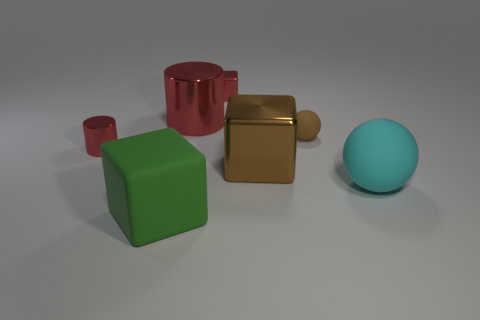The large matte thing on the right side of the big metallic object behind the brown object that is to the left of the brown matte thing is what color?
Offer a terse response. Cyan. How big is the rubber thing that is behind the big brown cube that is to the right of the large green matte block?
Give a very brief answer. Small. There is a cube that is on the right side of the large red cylinder and in front of the tiny brown ball; what material is it?
Give a very brief answer. Metal. Is the size of the cyan matte sphere the same as the matte thing to the left of the large brown metal thing?
Make the answer very short. Yes. Are there any large green rubber objects?
Your answer should be very brief. Yes. What material is the other tiny object that is the same shape as the green matte object?
Your answer should be very brief. Metal. What is the size of the rubber object that is left of the matte sphere on the left side of the cyan rubber object in front of the tiny ball?
Your answer should be very brief. Large. There is a small sphere; are there any rubber spheres to the right of it?
Your answer should be compact. Yes. The cyan ball that is made of the same material as the big green cube is what size?
Give a very brief answer. Large. How many big cyan things are the same shape as the big brown thing?
Offer a very short reply. 0. 